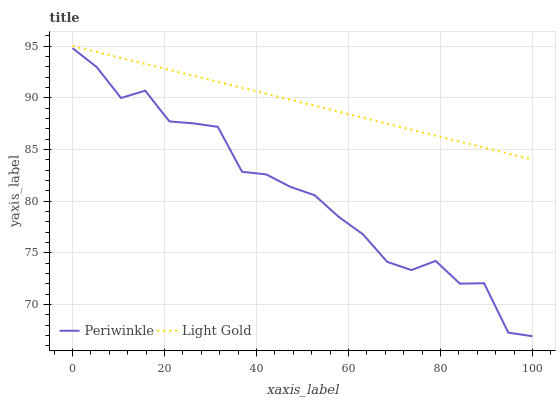Does Periwinkle have the minimum area under the curve?
Answer yes or no. Yes. Does Light Gold have the maximum area under the curve?
Answer yes or no. Yes. Does Periwinkle have the maximum area under the curve?
Answer yes or no. No. Is Light Gold the smoothest?
Answer yes or no. Yes. Is Periwinkle the roughest?
Answer yes or no. Yes. Is Periwinkle the smoothest?
Answer yes or no. No. Does Periwinkle have the lowest value?
Answer yes or no. Yes. Does Light Gold have the highest value?
Answer yes or no. Yes. Does Periwinkle have the highest value?
Answer yes or no. No. Is Periwinkle less than Light Gold?
Answer yes or no. Yes. Is Light Gold greater than Periwinkle?
Answer yes or no. Yes. Does Periwinkle intersect Light Gold?
Answer yes or no. No. 